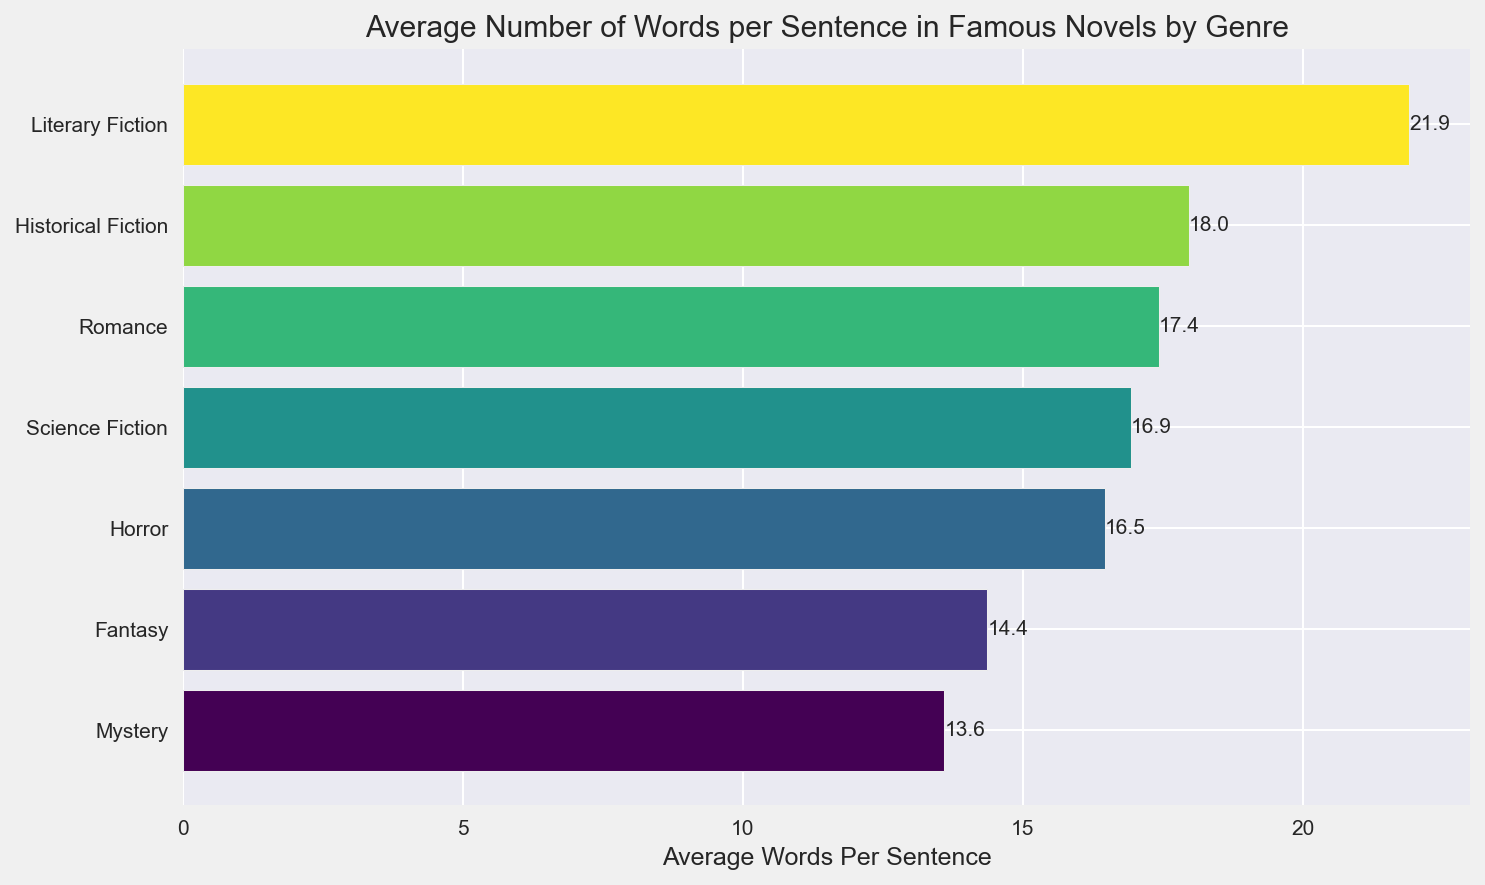What genre has the highest average number of words per sentence? To determine the genre with the highest average, look at the rightmost bar in the horizontal bar chart. This bar represents the genre with the highest value.
Answer: Literary Fiction Which genre has the lowest average number of words per sentence? To find the genre with the lowest average, examine the leftmost bar in the horizontal bar chart. This bar shows the genre with the lowest value.
Answer: Mystery What is the average number of words per sentence for the Romance genre? Locate the bar corresponding to the Romance genre in the bar chart. Note the numerical value annotated on the bar.
Answer: 17.4 How does the average number of words per sentence in Historical Fiction compare to that in Science Fiction? Identify the bars for Historical Fiction and Science Fiction in the chart. Then, compare their lengths and the annotated values to see which one is higher.
Answer: Historical Fiction is higher What is the difference in average words per sentence between the genre with the highest average and the genre with the lowest average? The highest average is awarded to Literary Fiction (30.1), while the lowest is attributed to Mystery (13.6). The difference is calculated as 30.1 - 13.6.
Answer: 16.5 Which genre has almost the same average words per sentence as Fantasy? Identify the bar for Fantasy (14.4) and check adjacent bars. Historical Fiction, with a value of 14.6, is closest.
Answer: Historical Fiction If a novel crosses over between Literary Fiction and Romance, what might be its average words per sentence? The average words per sentence for Literary Fiction is 30.1, and for Romance, it's 17.4. Calculate the average of these two to estimate for a crossover genre. (30.1 + 17.4) / 2
Answer: 23.75 Compare the average words per sentence of Fantasy and Horror genres. Examine the bars for Fantasy and Horror. The Fantasy average is 14.4, and Horror is 16.5. Therefore, Horror has a higher average.
Answer: Horror is higher 